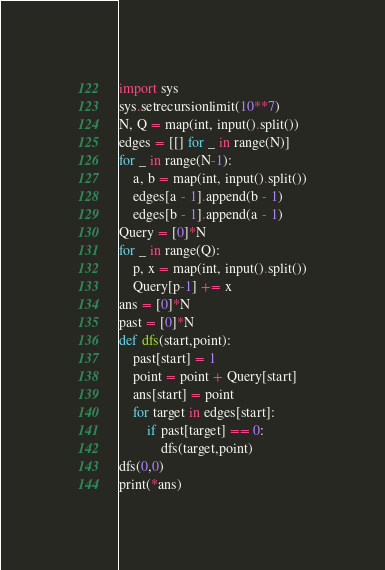Convert code to text. <code><loc_0><loc_0><loc_500><loc_500><_Python_>import sys
sys.setrecursionlimit(10**7)
N, Q = map(int, input().split())
edges = [[] for _ in range(N)]
for _ in range(N-1):
    a, b = map(int, input().split())
    edges[a - 1].append(b - 1)
    edges[b - 1].append(a - 1)
Query = [0]*N
for _ in range(Q):
    p, x = map(int, input().split())
    Query[p-1] += x
ans = [0]*N
past = [0]*N
def dfs(start,point):
    past[start] = 1
    point = point + Query[start]
    ans[start] = point
    for target in edges[start]:
        if past[target] == 0:
            dfs(target,point)
dfs(0,0)
print(*ans)</code> 